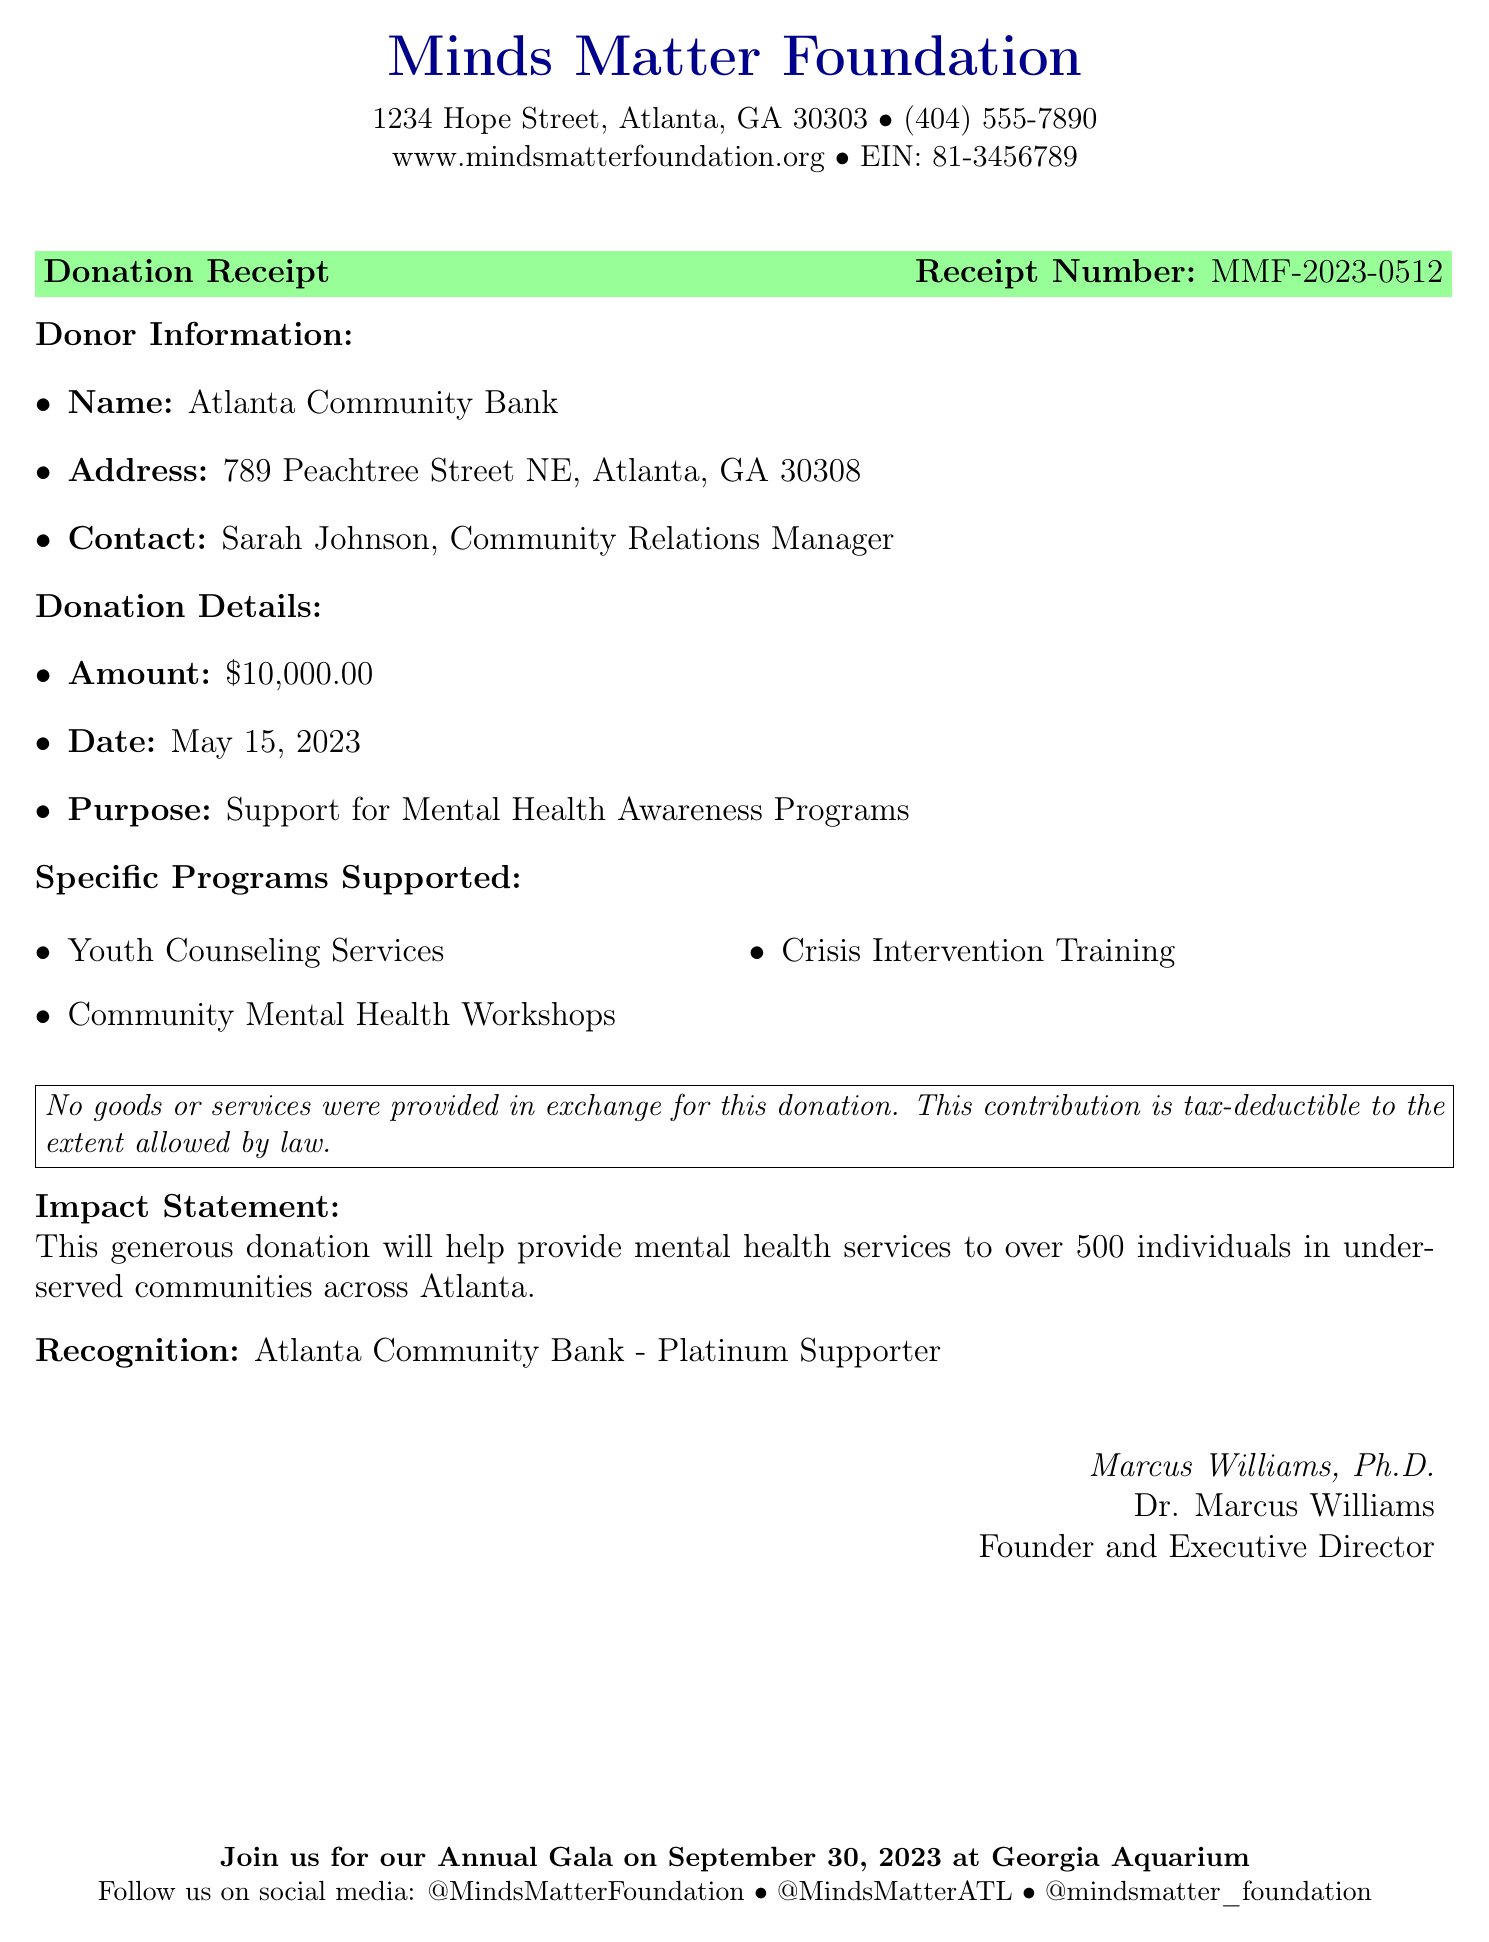What is the name of the organization? The name of the organization is stated in the document header and introduction.
Answer: Minds Matter Foundation What is the donation amount? The donation amount is clearly labeled in the Donation Details section of the document.
Answer: $10,000.00 Who is the contact person for the donor? The contact person for the donor is provided under Donor Information section.
Answer: Sarah Johnson, Community Relations Manager What is the purpose of the donation? The purpose of the donation is specified in the Donation Details section.
Answer: Support for Mental Health Awareness Programs When was the donation made? The date of the donation is indicated in the Donation Details section.
Answer: May 15, 2023 What is the receipt number? The receipt number is listed prominently in the document, labeled appropriately.
Answer: MMF-2023-0512 Which programs are supported by this donation? The specific programs supported are outlined in their respective section of the document.
Answer: Youth Counseling Services, Community Mental Health Workshops, Crisis Intervention Training What level of donor recognition is given? The level of donor recognition is mentioned at the end of the donation details.
Answer: Platinum Supporter Who signed the receipt? The signature line indicates the person who signed, which is also detailed in the document.
Answer: Marcus Williams, Ph.D 